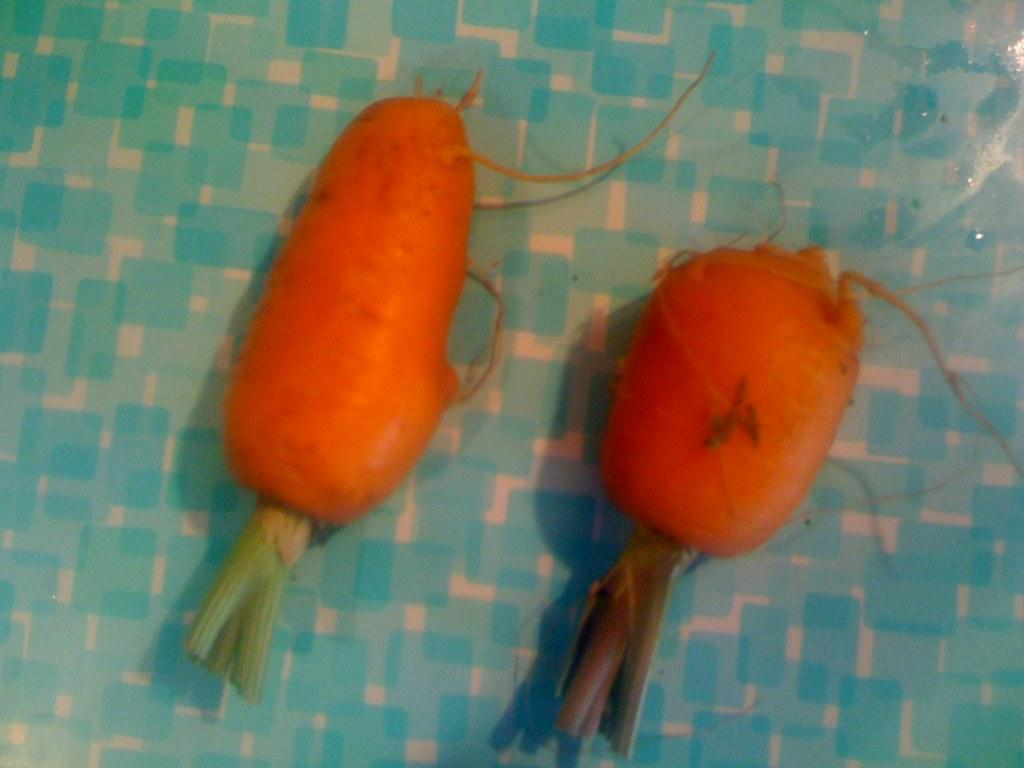What type of vegetable is present in the image? There are carrots in the image. Can you describe the object on which the carrots are placed? Unfortunately, the facts provided do not give any information about the object on which the carrots are placed. How many marbles are visible in the image? There are no marbles present in the image; it only features carrots. Is there an owl perched on top of the carrots in the image? There is no owl present in the image; it only features carrots. 